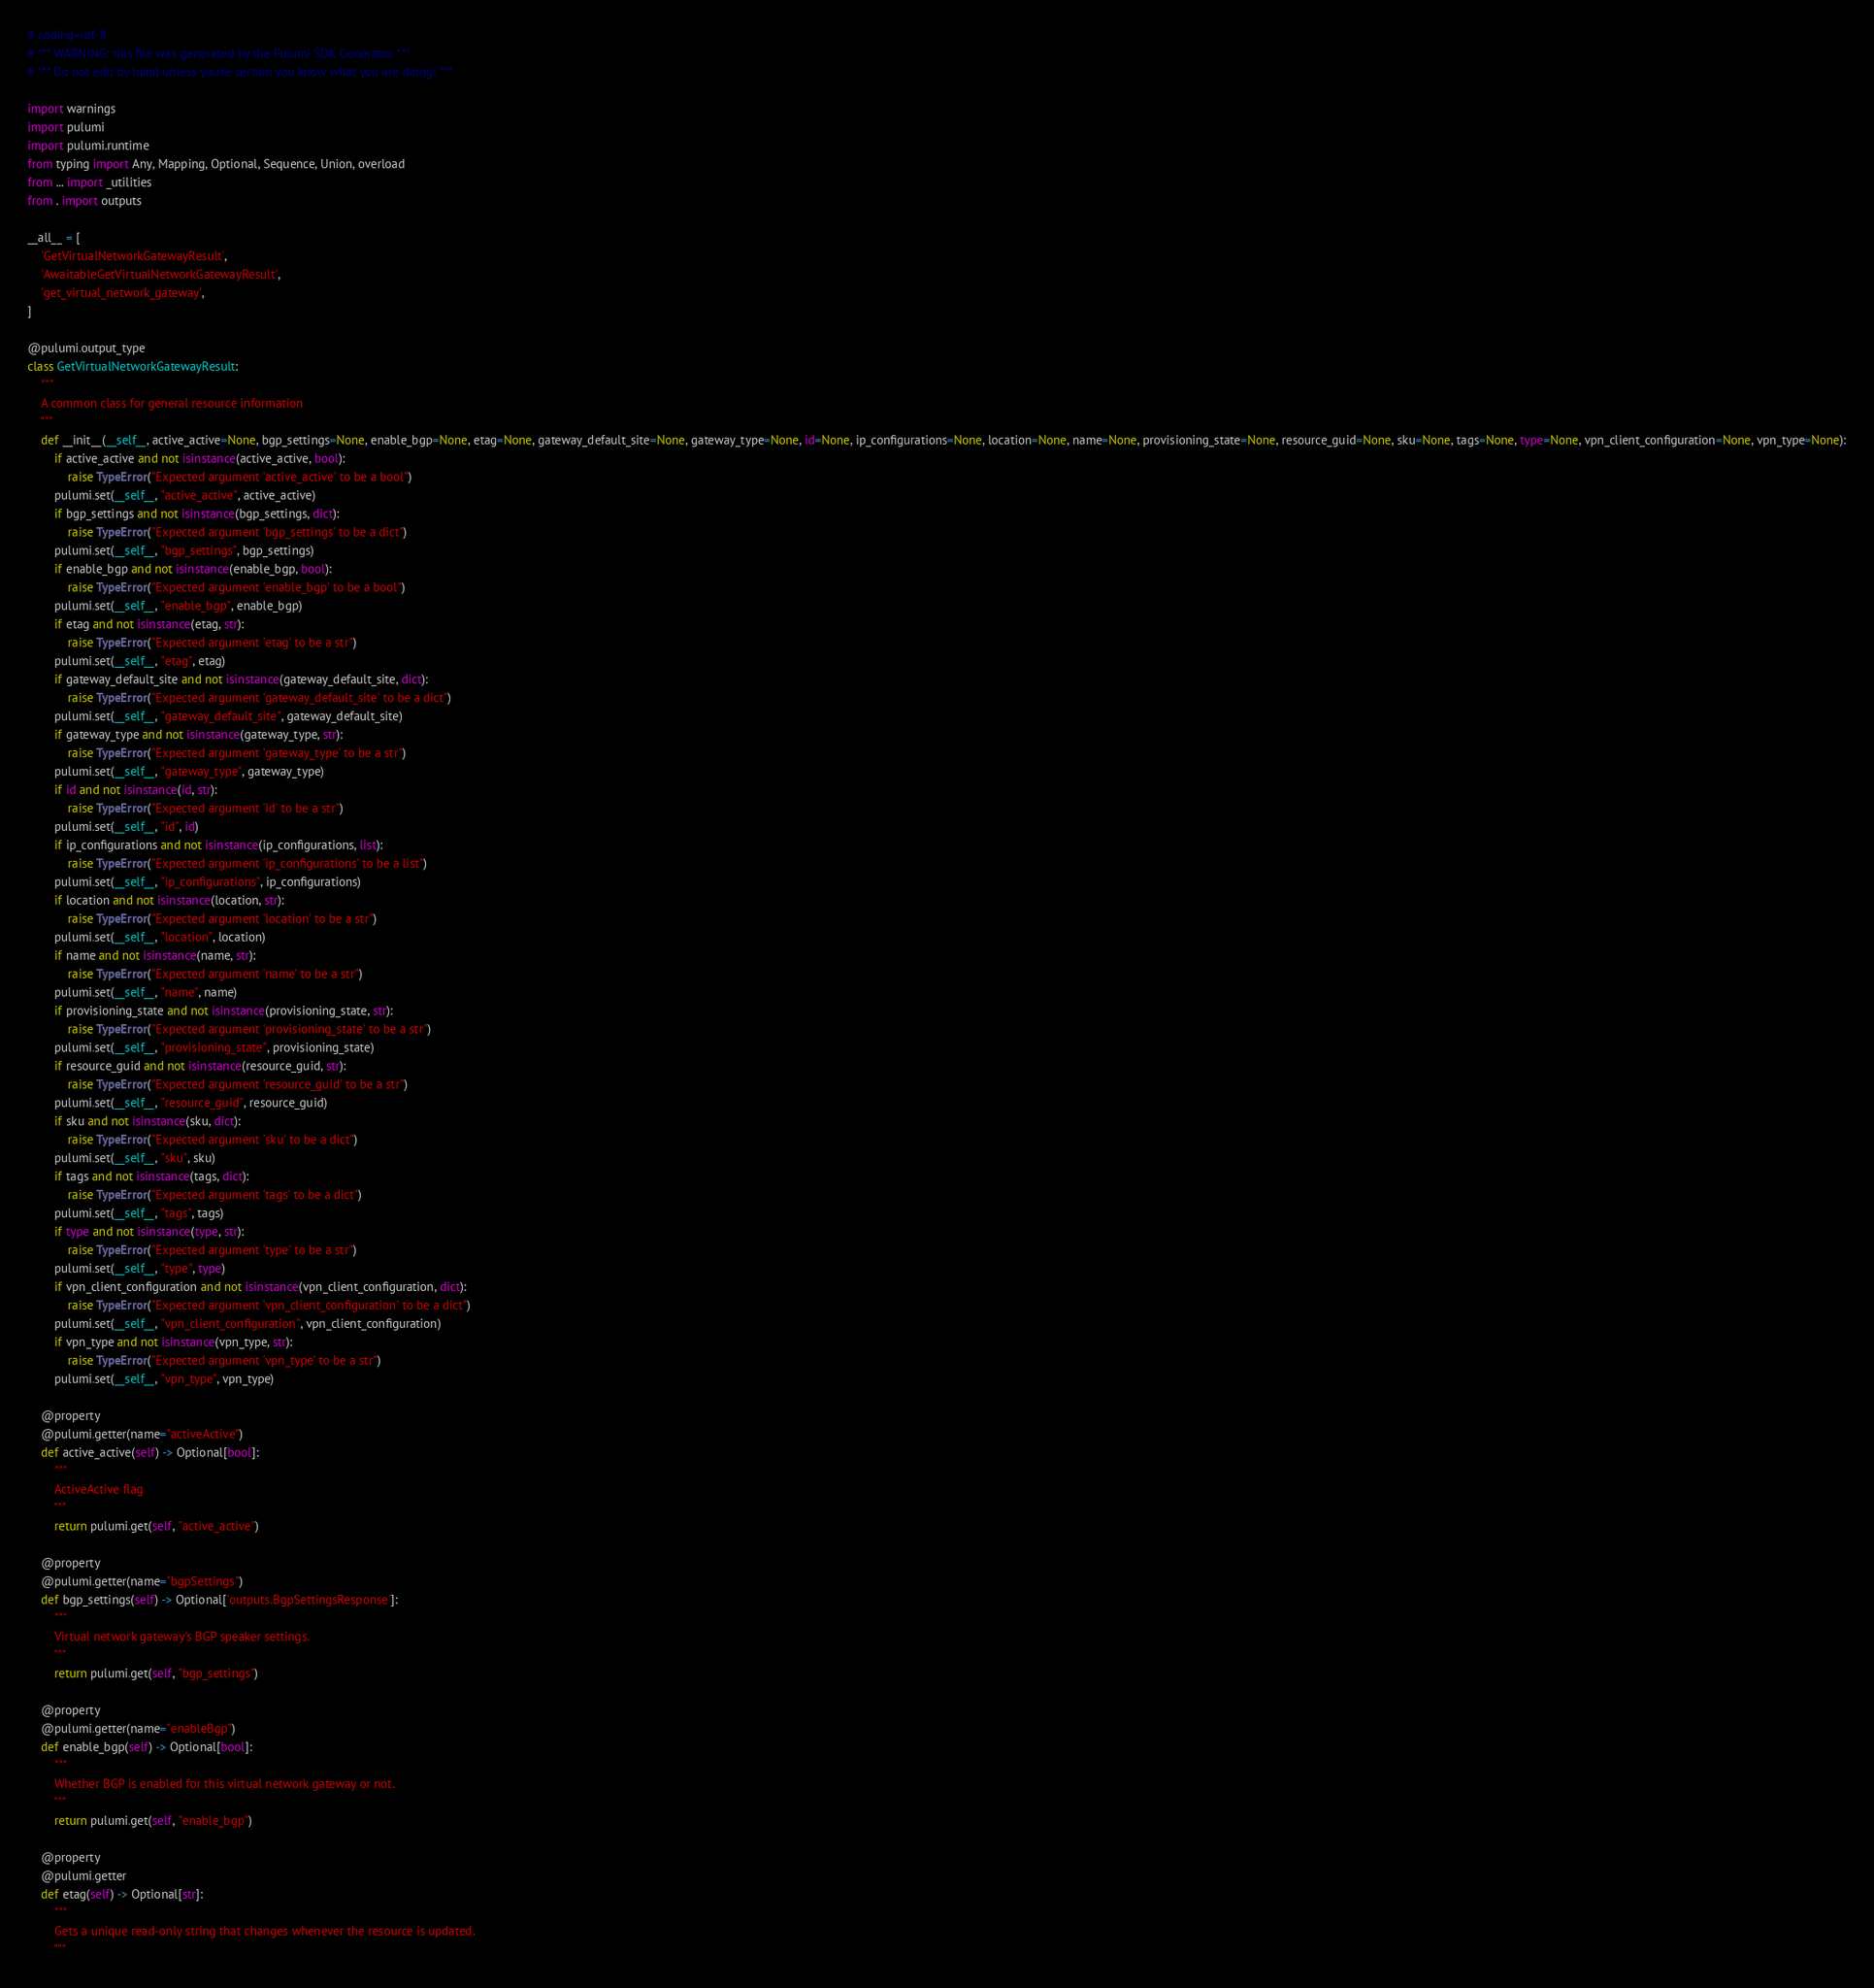<code> <loc_0><loc_0><loc_500><loc_500><_Python_># coding=utf-8
# *** WARNING: this file was generated by the Pulumi SDK Generator. ***
# *** Do not edit by hand unless you're certain you know what you are doing! ***

import warnings
import pulumi
import pulumi.runtime
from typing import Any, Mapping, Optional, Sequence, Union, overload
from ... import _utilities
from . import outputs

__all__ = [
    'GetVirtualNetworkGatewayResult',
    'AwaitableGetVirtualNetworkGatewayResult',
    'get_virtual_network_gateway',
]

@pulumi.output_type
class GetVirtualNetworkGatewayResult:
    """
    A common class for general resource information
    """
    def __init__(__self__, active_active=None, bgp_settings=None, enable_bgp=None, etag=None, gateway_default_site=None, gateway_type=None, id=None, ip_configurations=None, location=None, name=None, provisioning_state=None, resource_guid=None, sku=None, tags=None, type=None, vpn_client_configuration=None, vpn_type=None):
        if active_active and not isinstance(active_active, bool):
            raise TypeError("Expected argument 'active_active' to be a bool")
        pulumi.set(__self__, "active_active", active_active)
        if bgp_settings and not isinstance(bgp_settings, dict):
            raise TypeError("Expected argument 'bgp_settings' to be a dict")
        pulumi.set(__self__, "bgp_settings", bgp_settings)
        if enable_bgp and not isinstance(enable_bgp, bool):
            raise TypeError("Expected argument 'enable_bgp' to be a bool")
        pulumi.set(__self__, "enable_bgp", enable_bgp)
        if etag and not isinstance(etag, str):
            raise TypeError("Expected argument 'etag' to be a str")
        pulumi.set(__self__, "etag", etag)
        if gateway_default_site and not isinstance(gateway_default_site, dict):
            raise TypeError("Expected argument 'gateway_default_site' to be a dict")
        pulumi.set(__self__, "gateway_default_site", gateway_default_site)
        if gateway_type and not isinstance(gateway_type, str):
            raise TypeError("Expected argument 'gateway_type' to be a str")
        pulumi.set(__self__, "gateway_type", gateway_type)
        if id and not isinstance(id, str):
            raise TypeError("Expected argument 'id' to be a str")
        pulumi.set(__self__, "id", id)
        if ip_configurations and not isinstance(ip_configurations, list):
            raise TypeError("Expected argument 'ip_configurations' to be a list")
        pulumi.set(__self__, "ip_configurations", ip_configurations)
        if location and not isinstance(location, str):
            raise TypeError("Expected argument 'location' to be a str")
        pulumi.set(__self__, "location", location)
        if name and not isinstance(name, str):
            raise TypeError("Expected argument 'name' to be a str")
        pulumi.set(__self__, "name", name)
        if provisioning_state and not isinstance(provisioning_state, str):
            raise TypeError("Expected argument 'provisioning_state' to be a str")
        pulumi.set(__self__, "provisioning_state", provisioning_state)
        if resource_guid and not isinstance(resource_guid, str):
            raise TypeError("Expected argument 'resource_guid' to be a str")
        pulumi.set(__self__, "resource_guid", resource_guid)
        if sku and not isinstance(sku, dict):
            raise TypeError("Expected argument 'sku' to be a dict")
        pulumi.set(__self__, "sku", sku)
        if tags and not isinstance(tags, dict):
            raise TypeError("Expected argument 'tags' to be a dict")
        pulumi.set(__self__, "tags", tags)
        if type and not isinstance(type, str):
            raise TypeError("Expected argument 'type' to be a str")
        pulumi.set(__self__, "type", type)
        if vpn_client_configuration and not isinstance(vpn_client_configuration, dict):
            raise TypeError("Expected argument 'vpn_client_configuration' to be a dict")
        pulumi.set(__self__, "vpn_client_configuration", vpn_client_configuration)
        if vpn_type and not isinstance(vpn_type, str):
            raise TypeError("Expected argument 'vpn_type' to be a str")
        pulumi.set(__self__, "vpn_type", vpn_type)

    @property
    @pulumi.getter(name="activeActive")
    def active_active(self) -> Optional[bool]:
        """
        ActiveActive flag
        """
        return pulumi.get(self, "active_active")

    @property
    @pulumi.getter(name="bgpSettings")
    def bgp_settings(self) -> Optional['outputs.BgpSettingsResponse']:
        """
        Virtual network gateway's BGP speaker settings.
        """
        return pulumi.get(self, "bgp_settings")

    @property
    @pulumi.getter(name="enableBgp")
    def enable_bgp(self) -> Optional[bool]:
        """
        Whether BGP is enabled for this virtual network gateway or not.
        """
        return pulumi.get(self, "enable_bgp")

    @property
    @pulumi.getter
    def etag(self) -> Optional[str]:
        """
        Gets a unique read-only string that changes whenever the resource is updated.
        """</code> 